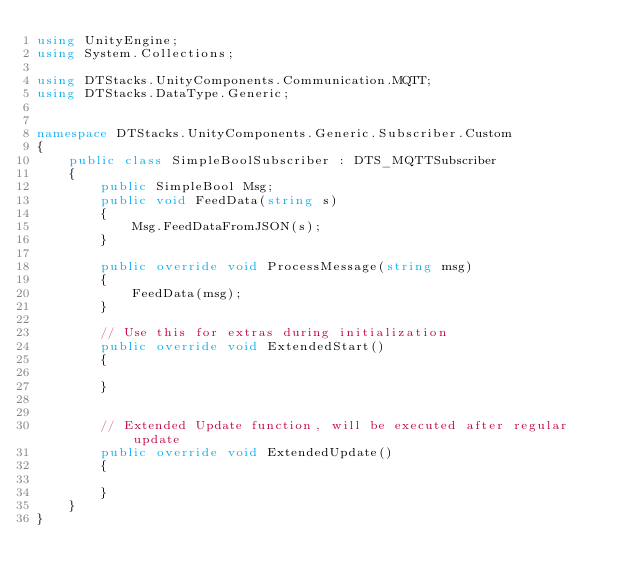Convert code to text. <code><loc_0><loc_0><loc_500><loc_500><_C#_>using UnityEngine;
using System.Collections;

using DTStacks.UnityComponents.Communication.MQTT;
using DTStacks.DataType.Generic;


namespace DTStacks.UnityComponents.Generic.Subscriber.Custom
{
    public class SimpleBoolSubscriber : DTS_MQTTSubscriber
    {
        public SimpleBool Msg;
        public void FeedData(string s)
        {
            Msg.FeedDataFromJSON(s);
        }

        public override void ProcessMessage(string msg)
        {
            FeedData(msg);
        }

        // Use this for extras during initialization
        public override void ExtendedStart()
        {

        }


        // Extended Update function, will be executed after regular update
        public override void ExtendedUpdate()
        {

        }
    }
}
</code> 